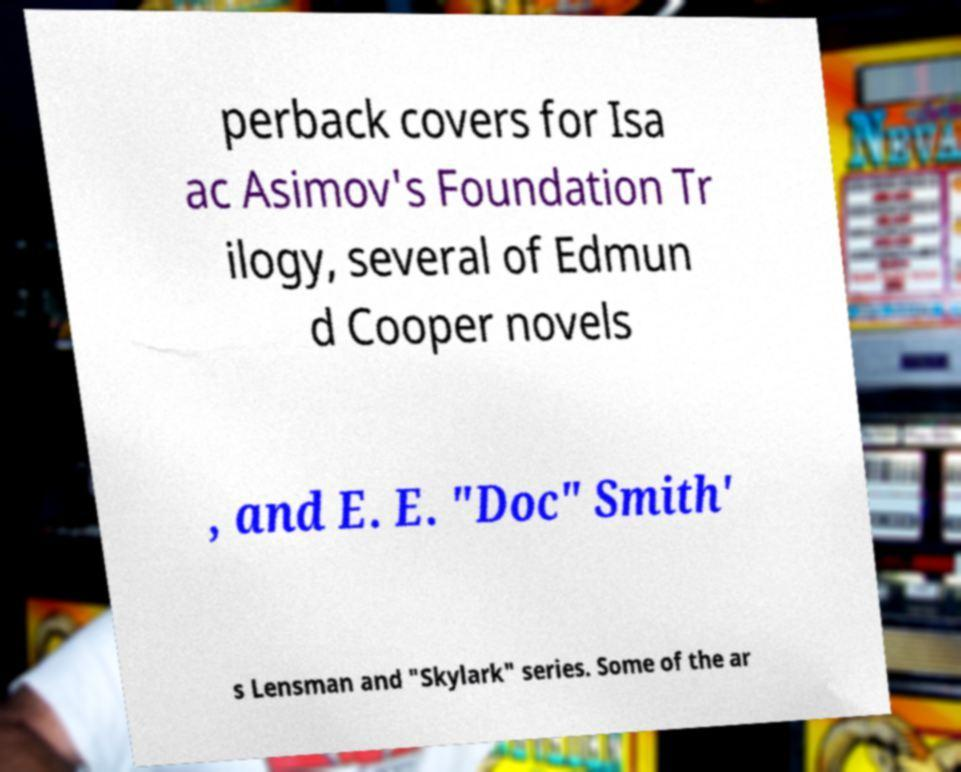I need the written content from this picture converted into text. Can you do that? perback covers for Isa ac Asimov's Foundation Tr ilogy, several of Edmun d Cooper novels , and E. E. "Doc" Smith' s Lensman and "Skylark" series. Some of the ar 